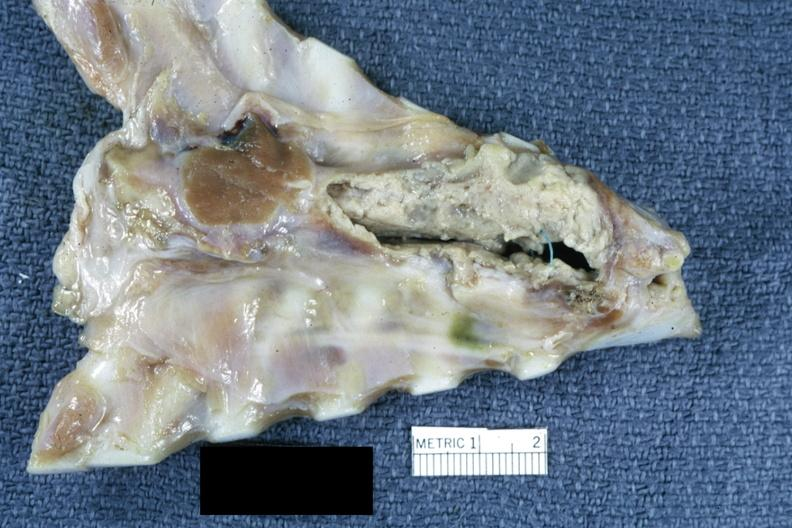what is present?
Answer the question using a single word or phrase. Mediastinal abscess 